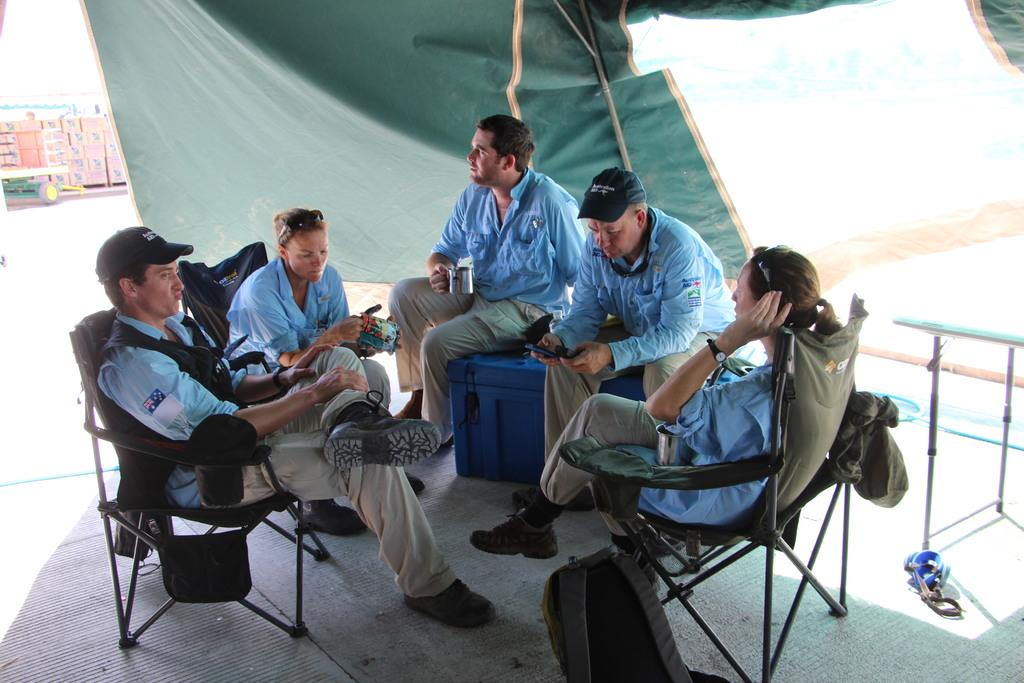How many people are present in the image? There are five people in the image. Where are the people located in the image? The people are sitting in a tent. What type of seating is available in the tent? Some of the people are sitting on chairs, and two people are sitting on a box. What color is the moon in the image? There is no moon present in the image. How does the throat of the person sitting on the box feel in the image? There is no information about the throat of any person in the image. 